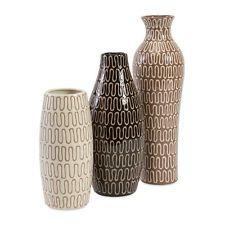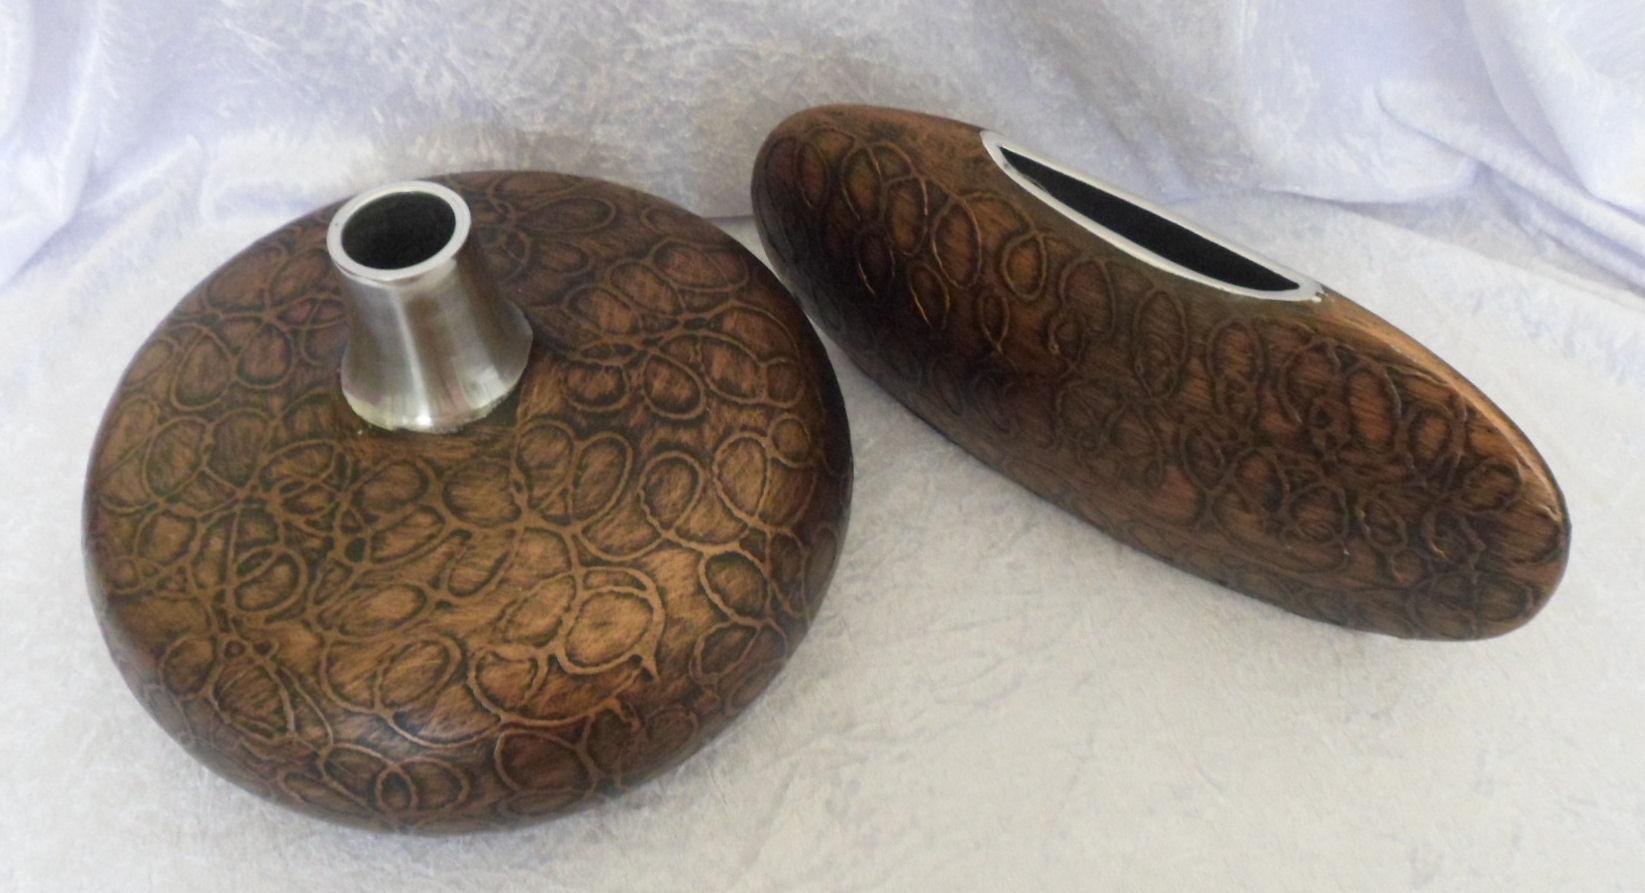The first image is the image on the left, the second image is the image on the right. Evaluate the accuracy of this statement regarding the images: "The left image contains a set of three vases with similar patterns but different shapes and heights.". Is it true? Answer yes or no. Yes. The first image is the image on the left, the second image is the image on the right. Assess this claim about the two images: "there are three vases of varying sizes". Correct or not? Answer yes or no. Yes. 